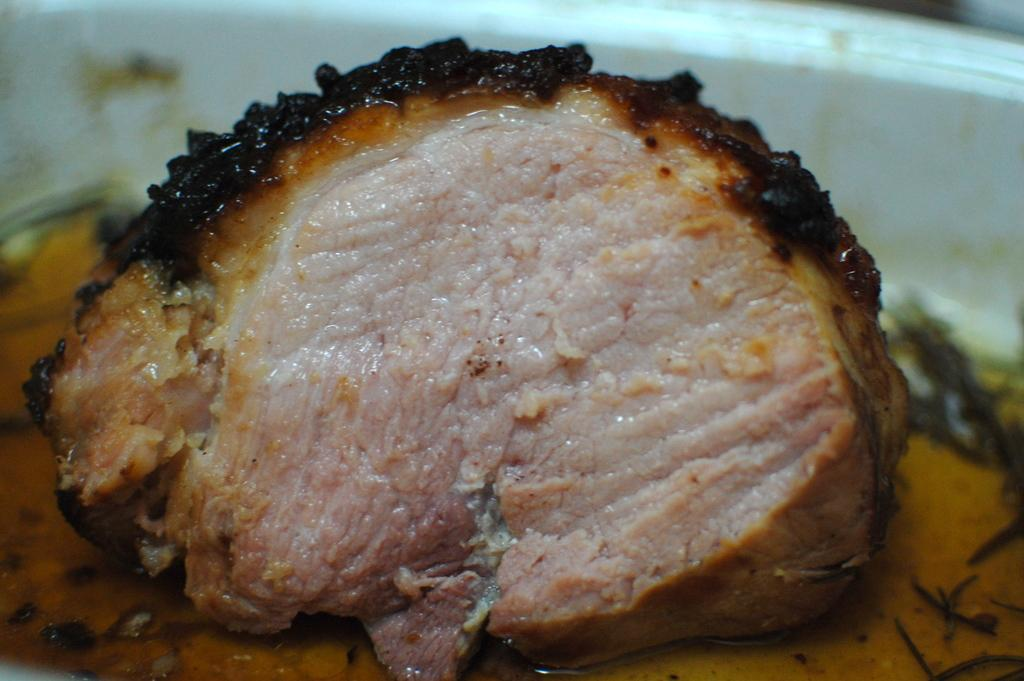What is in the bowl that is visible in the image? There is a bowl in the image that contains a slice of fried meat and soup. What type of food is in the bowl? The bowl contains a slice of fried meat and soup. How does the zipper on the bowl function in the image? There is no zipper present on the bowl in the image. 